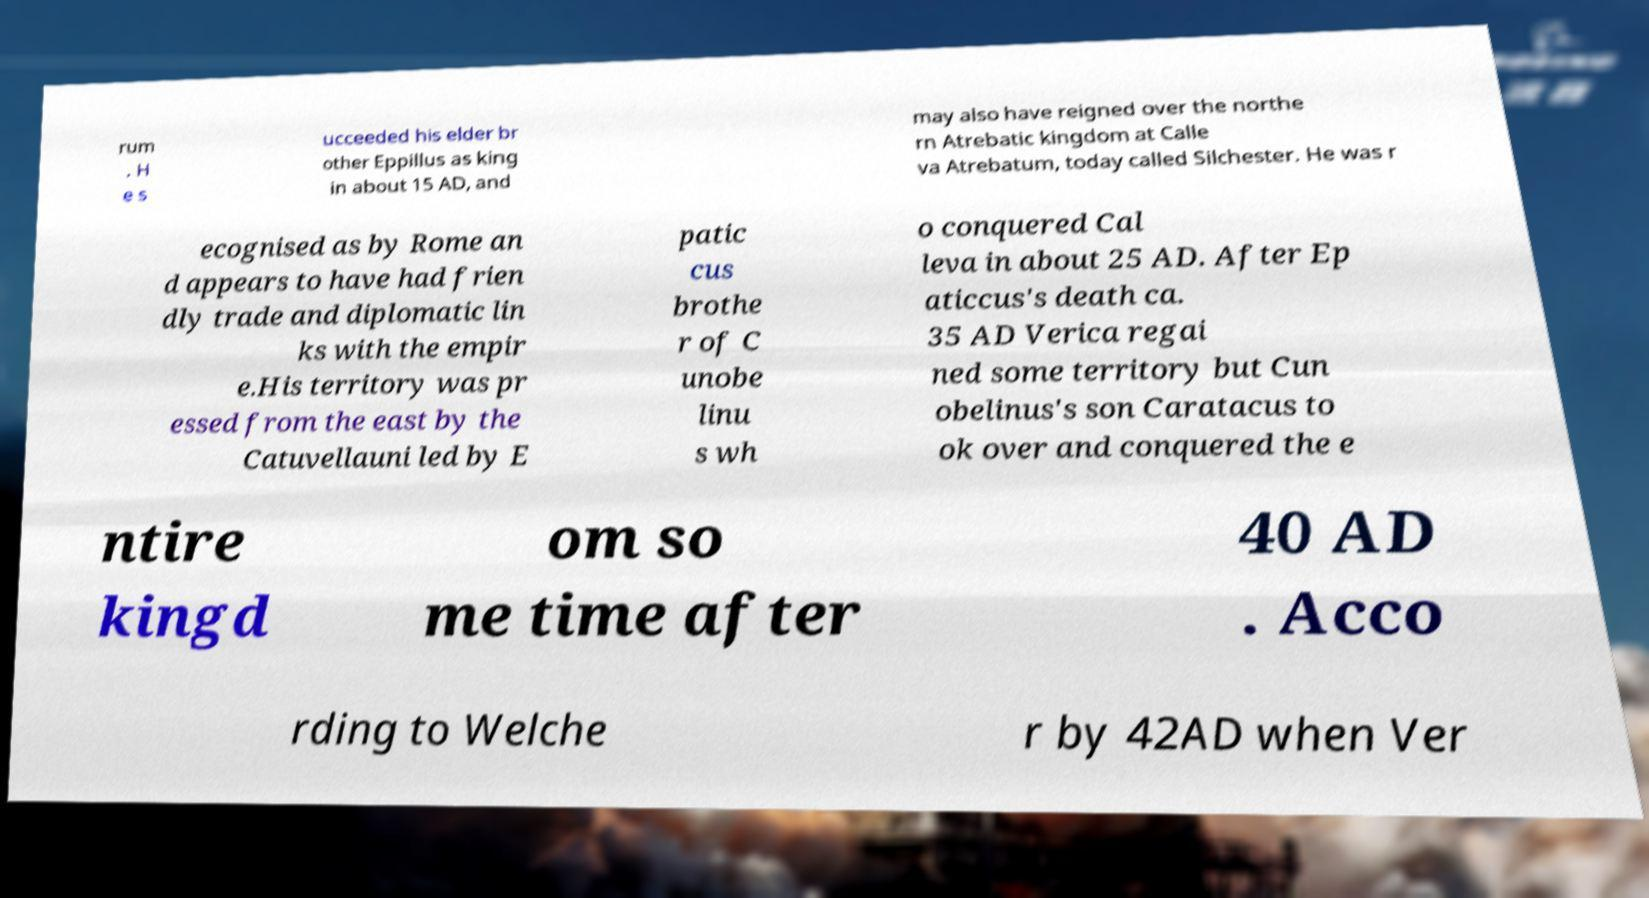For documentation purposes, I need the text within this image transcribed. Could you provide that? rum . H e s ucceeded his elder br other Eppillus as king in about 15 AD, and may also have reigned over the northe rn Atrebatic kingdom at Calle va Atrebatum, today called Silchester. He was r ecognised as by Rome an d appears to have had frien dly trade and diplomatic lin ks with the empir e.His territory was pr essed from the east by the Catuvellauni led by E patic cus brothe r of C unobe linu s wh o conquered Cal leva in about 25 AD. After Ep aticcus's death ca. 35 AD Verica regai ned some territory but Cun obelinus's son Caratacus to ok over and conquered the e ntire kingd om so me time after 40 AD . Acco rding to Welche r by 42AD when Ver 